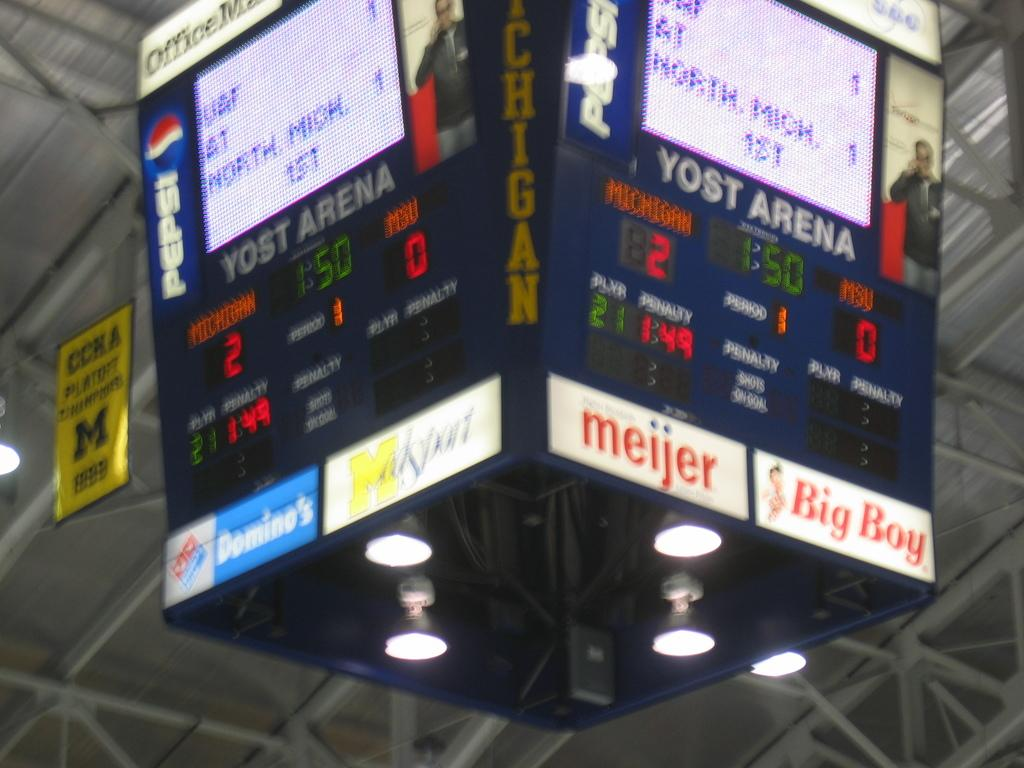<image>
Render a clear and concise summary of the photo. A score screen at Yost Arena for MSU versus Michigan. 